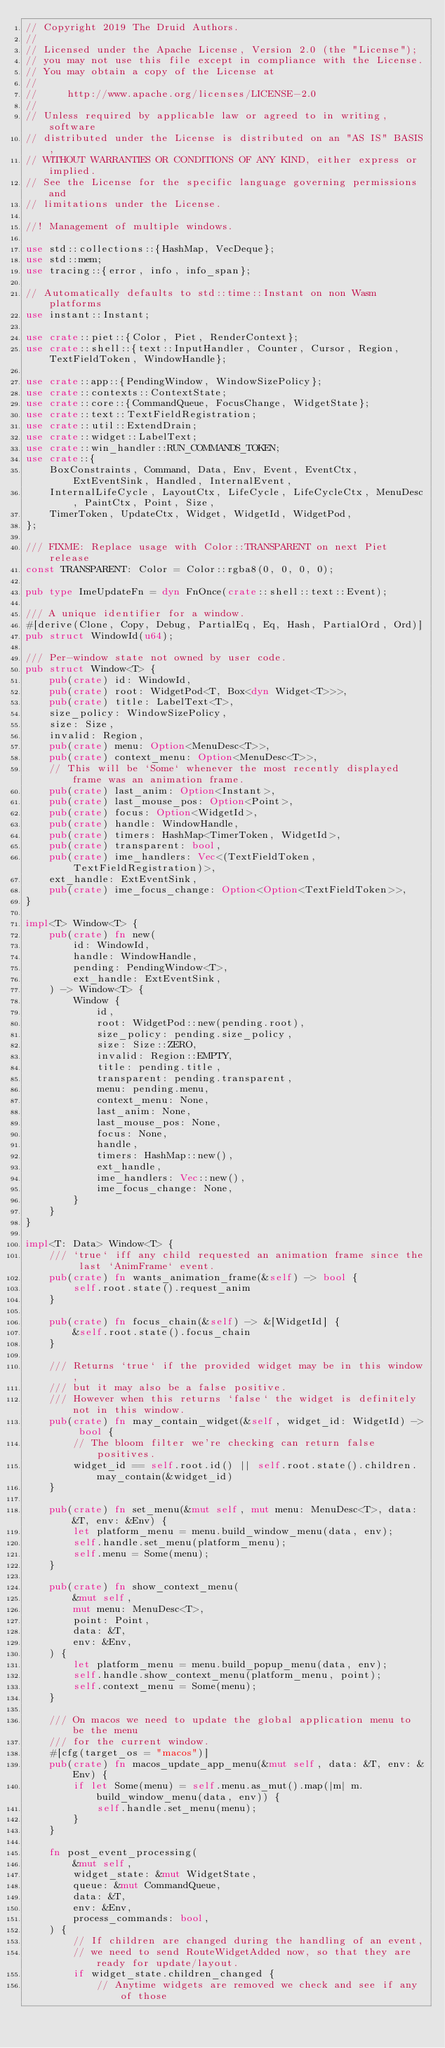<code> <loc_0><loc_0><loc_500><loc_500><_Rust_>// Copyright 2019 The Druid Authors.
//
// Licensed under the Apache License, Version 2.0 (the "License");
// you may not use this file except in compliance with the License.
// You may obtain a copy of the License at
//
//     http://www.apache.org/licenses/LICENSE-2.0
//
// Unless required by applicable law or agreed to in writing, software
// distributed under the License is distributed on an "AS IS" BASIS,
// WITHOUT WARRANTIES OR CONDITIONS OF ANY KIND, either express or implied.
// See the License for the specific language governing permissions and
// limitations under the License.

//! Management of multiple windows.

use std::collections::{HashMap, VecDeque};
use std::mem;
use tracing::{error, info, info_span};

// Automatically defaults to std::time::Instant on non Wasm platforms
use instant::Instant;

use crate::piet::{Color, Piet, RenderContext};
use crate::shell::{text::InputHandler, Counter, Cursor, Region, TextFieldToken, WindowHandle};

use crate::app::{PendingWindow, WindowSizePolicy};
use crate::contexts::ContextState;
use crate::core::{CommandQueue, FocusChange, WidgetState};
use crate::text::TextFieldRegistration;
use crate::util::ExtendDrain;
use crate::widget::LabelText;
use crate::win_handler::RUN_COMMANDS_TOKEN;
use crate::{
    BoxConstraints, Command, Data, Env, Event, EventCtx, ExtEventSink, Handled, InternalEvent,
    InternalLifeCycle, LayoutCtx, LifeCycle, LifeCycleCtx, MenuDesc, PaintCtx, Point, Size,
    TimerToken, UpdateCtx, Widget, WidgetId, WidgetPod,
};

/// FIXME: Replace usage with Color::TRANSPARENT on next Piet release
const TRANSPARENT: Color = Color::rgba8(0, 0, 0, 0);

pub type ImeUpdateFn = dyn FnOnce(crate::shell::text::Event);

/// A unique identifier for a window.
#[derive(Clone, Copy, Debug, PartialEq, Eq, Hash, PartialOrd, Ord)]
pub struct WindowId(u64);

/// Per-window state not owned by user code.
pub struct Window<T> {
    pub(crate) id: WindowId,
    pub(crate) root: WidgetPod<T, Box<dyn Widget<T>>>,
    pub(crate) title: LabelText<T>,
    size_policy: WindowSizePolicy,
    size: Size,
    invalid: Region,
    pub(crate) menu: Option<MenuDesc<T>>,
    pub(crate) context_menu: Option<MenuDesc<T>>,
    // This will be `Some` whenever the most recently displayed frame was an animation frame.
    pub(crate) last_anim: Option<Instant>,
    pub(crate) last_mouse_pos: Option<Point>,
    pub(crate) focus: Option<WidgetId>,
    pub(crate) handle: WindowHandle,
    pub(crate) timers: HashMap<TimerToken, WidgetId>,
    pub(crate) transparent: bool,
    pub(crate) ime_handlers: Vec<(TextFieldToken, TextFieldRegistration)>,
    ext_handle: ExtEventSink,
    pub(crate) ime_focus_change: Option<Option<TextFieldToken>>,
}

impl<T> Window<T> {
    pub(crate) fn new(
        id: WindowId,
        handle: WindowHandle,
        pending: PendingWindow<T>,
        ext_handle: ExtEventSink,
    ) -> Window<T> {
        Window {
            id,
            root: WidgetPod::new(pending.root),
            size_policy: pending.size_policy,
            size: Size::ZERO,
            invalid: Region::EMPTY,
            title: pending.title,
            transparent: pending.transparent,
            menu: pending.menu,
            context_menu: None,
            last_anim: None,
            last_mouse_pos: None,
            focus: None,
            handle,
            timers: HashMap::new(),
            ext_handle,
            ime_handlers: Vec::new(),
            ime_focus_change: None,
        }
    }
}

impl<T: Data> Window<T> {
    /// `true` iff any child requested an animation frame since the last `AnimFrame` event.
    pub(crate) fn wants_animation_frame(&self) -> bool {
        self.root.state().request_anim
    }

    pub(crate) fn focus_chain(&self) -> &[WidgetId] {
        &self.root.state().focus_chain
    }

    /// Returns `true` if the provided widget may be in this window,
    /// but it may also be a false positive.
    /// However when this returns `false` the widget is definitely not in this window.
    pub(crate) fn may_contain_widget(&self, widget_id: WidgetId) -> bool {
        // The bloom filter we're checking can return false positives.
        widget_id == self.root.id() || self.root.state().children.may_contain(&widget_id)
    }

    pub(crate) fn set_menu(&mut self, mut menu: MenuDesc<T>, data: &T, env: &Env) {
        let platform_menu = menu.build_window_menu(data, env);
        self.handle.set_menu(platform_menu);
        self.menu = Some(menu);
    }

    pub(crate) fn show_context_menu(
        &mut self,
        mut menu: MenuDesc<T>,
        point: Point,
        data: &T,
        env: &Env,
    ) {
        let platform_menu = menu.build_popup_menu(data, env);
        self.handle.show_context_menu(platform_menu, point);
        self.context_menu = Some(menu);
    }

    /// On macos we need to update the global application menu to be the menu
    /// for the current window.
    #[cfg(target_os = "macos")]
    pub(crate) fn macos_update_app_menu(&mut self, data: &T, env: &Env) {
        if let Some(menu) = self.menu.as_mut().map(|m| m.build_window_menu(data, env)) {
            self.handle.set_menu(menu);
        }
    }

    fn post_event_processing(
        &mut self,
        widget_state: &mut WidgetState,
        queue: &mut CommandQueue,
        data: &T,
        env: &Env,
        process_commands: bool,
    ) {
        // If children are changed during the handling of an event,
        // we need to send RouteWidgetAdded now, so that they are ready for update/layout.
        if widget_state.children_changed {
            // Anytime widgets are removed we check and see if any of those</code> 